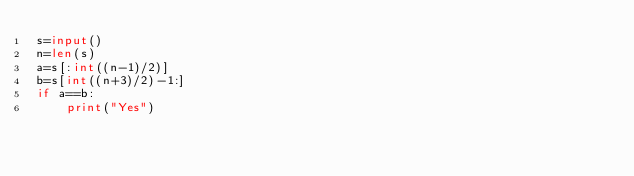Convert code to text. <code><loc_0><loc_0><loc_500><loc_500><_Python_>s=input()
n=len(s)
a=s[:int((n-1)/2)]
b=s[int((n+3)/2)-1:]
if a==b:
    print("Yes")</code> 